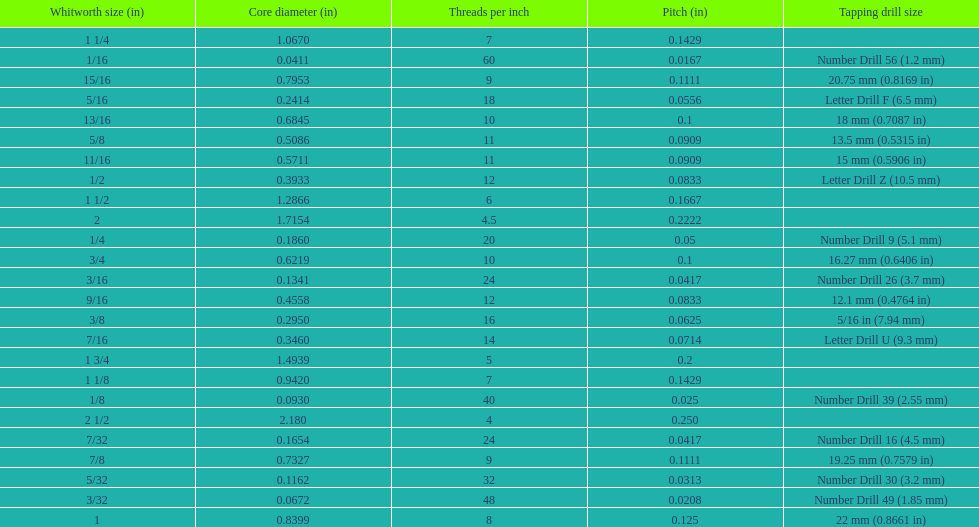What is the core diameter of the first 1/8 whitworth size (in)? 0.0930. 